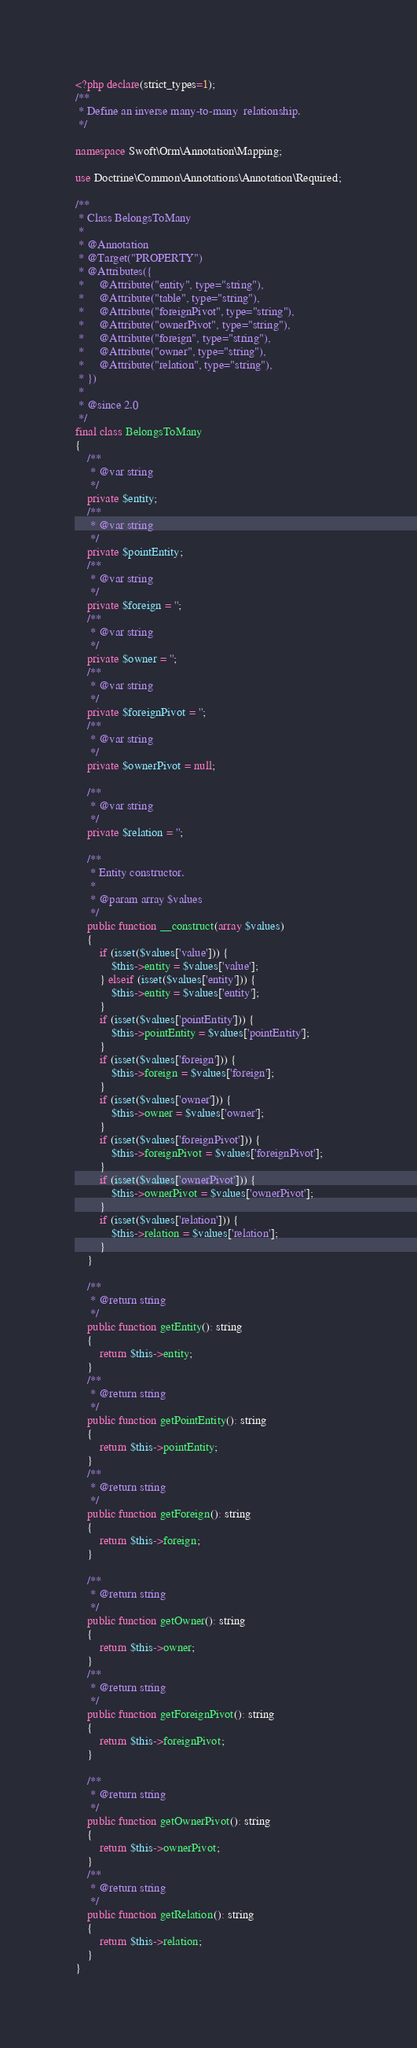<code> <loc_0><loc_0><loc_500><loc_500><_PHP_><?php declare(strict_types=1);
/**
 * Define an inverse many-to-many  relationship.
 */

namespace Swoft\Orm\Annotation\Mapping;

use Doctrine\Common\Annotations\Annotation\Required;

/**
 * Class BelongsToMany
 *
 * @Annotation
 * @Target("PROPERTY")
 * @Attributes({
 *     @Attribute("entity", type="string"),
 *     @Attribute("table", type="string"),
 *     @Attribute("foreignPivot", type="string"),
 *     @Attribute("ownerPivot", type="string"),
 *     @Attribute("foreign", type="string"),
 *     @Attribute("owner", type="string"),
 *     @Attribute("relation", type="string"),
 * })
 *
 * @since 2.0
 */
final class BelongsToMany
{
    /**
     * @var string
     */
    private $entity;
    /**
     * @var string
     */
    private $pointEntity;
    /**
     * @var string
     */
    private $foreign = '';
    /**
     * @var string
     */
    private $owner = '';
    /**
     * @var string
     */
    private $foreignPivot = '';
    /**
     * @var string
     */
    private $ownerPivot = null;

    /**
     * @var string
     */
    private $relation = '';

    /**
     * Entity constructor.
     *
     * @param array $values
     */
    public function __construct(array $values)
    {
        if (isset($values['value'])) {
            $this->entity = $values['value'];
        } elseif (isset($values['entity'])) {
            $this->entity = $values['entity'];
        }
        if (isset($values['pointEntity'])) {
            $this->pointEntity = $values['pointEntity'];
        }
        if (isset($values['foreign'])) {
            $this->foreign = $values['foreign'];
        }
        if (isset($values['owner'])) {
            $this->owner = $values['owner'];
        }
        if (isset($values['foreignPivot'])) {
            $this->foreignPivot = $values['foreignPivot'];
        }
        if (isset($values['ownerPivot'])) {
            $this->ownerPivot = $values['ownerPivot'];
        }
        if (isset($values['relation'])) {
            $this->relation = $values['relation'];
        }
    }

    /**
     * @return string
     */
    public function getEntity(): string
    {
        return $this->entity;
    }
    /**
     * @return string
     */
    public function getPointEntity(): string
    {
        return $this->pointEntity;
    }
    /**
     * @return string
     */
    public function getForeign(): string
    {
        return $this->foreign;
    }

    /**
     * @return string
     */
    public function getOwner(): string
    {
        return $this->owner;
    }
    /**
     * @return string
     */
    public function getForeignPivot(): string
    {
        return $this->foreignPivot;
    }

    /**
     * @return string
     */
    public function getOwnerPivot(): string
    {
        return $this->ownerPivot;
    }
    /**
     * @return string
     */
    public function getRelation(): string
    {
        return $this->relation;
    }
}
</code> 